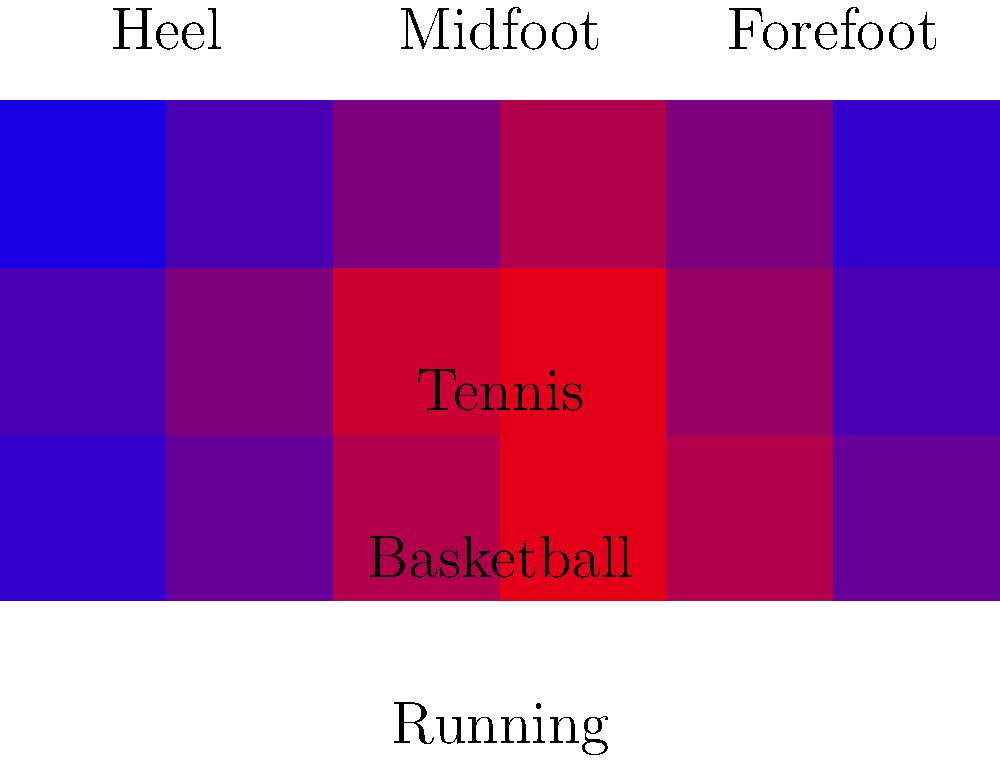Based on the heat map showing impact force distribution across different types of athletic shoes, which shoe type exhibits the highest peak force in the forefoot region? To answer this question, we need to analyze the heat map for each shoe type, focusing on the forefoot region:

1. Identify the forefoot region: It's the rightmost two columns of each row.

2. Analyze each shoe type:
   a) Running shoe (top row):
      Forefoot values: 0.7 and 0.4 (bright red to orange)
   
   b) Basketball shoe (middle row):
      Forefoot values: 0.6 and 0.3 (orange to yellow-green)
   
   c) Tennis shoe (bottom row):
      Forefoot values: 0.5 and 0.2 (yellow-green to blue)

3. Compare the peak values:
   Running shoe: 0.7
   Basketball shoe: 0.6
   Tennis shoe: 0.5

4. Identify the highest peak force:
   The running shoe has the highest peak force of 0.7 in the forefoot region.

This distribution is consistent with the biomechanics of running, where a significant amount of force is applied to the forefoot during the push-off phase of the gait cycle.
Answer: Running shoe 